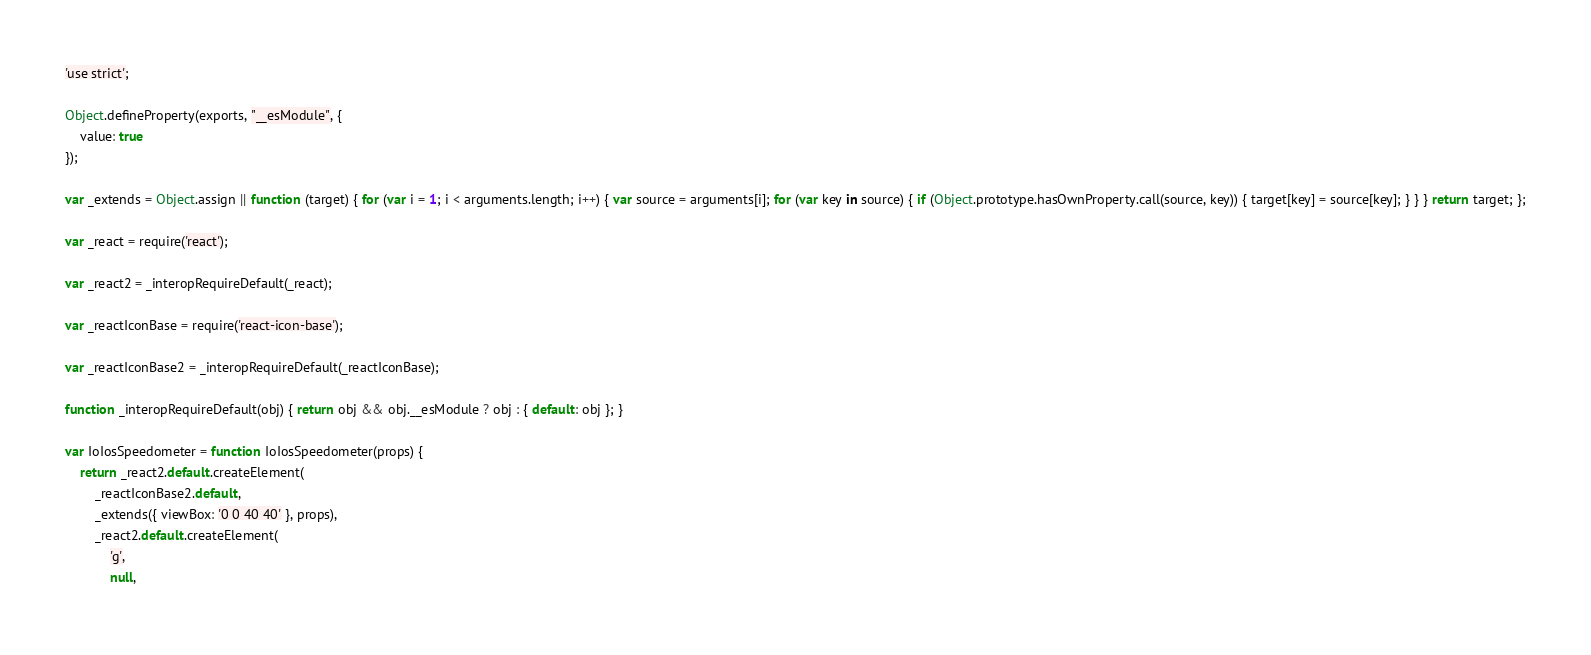<code> <loc_0><loc_0><loc_500><loc_500><_JavaScript_>'use strict';

Object.defineProperty(exports, "__esModule", {
    value: true
});

var _extends = Object.assign || function (target) { for (var i = 1; i < arguments.length; i++) { var source = arguments[i]; for (var key in source) { if (Object.prototype.hasOwnProperty.call(source, key)) { target[key] = source[key]; } } } return target; };

var _react = require('react');

var _react2 = _interopRequireDefault(_react);

var _reactIconBase = require('react-icon-base');

var _reactIconBase2 = _interopRequireDefault(_reactIconBase);

function _interopRequireDefault(obj) { return obj && obj.__esModule ? obj : { default: obj }; }

var IoIosSpeedometer = function IoIosSpeedometer(props) {
    return _react2.default.createElement(
        _reactIconBase2.default,
        _extends({ viewBox: '0 0 40 40' }, props),
        _react2.default.createElement(
            'g',
            null,</code> 